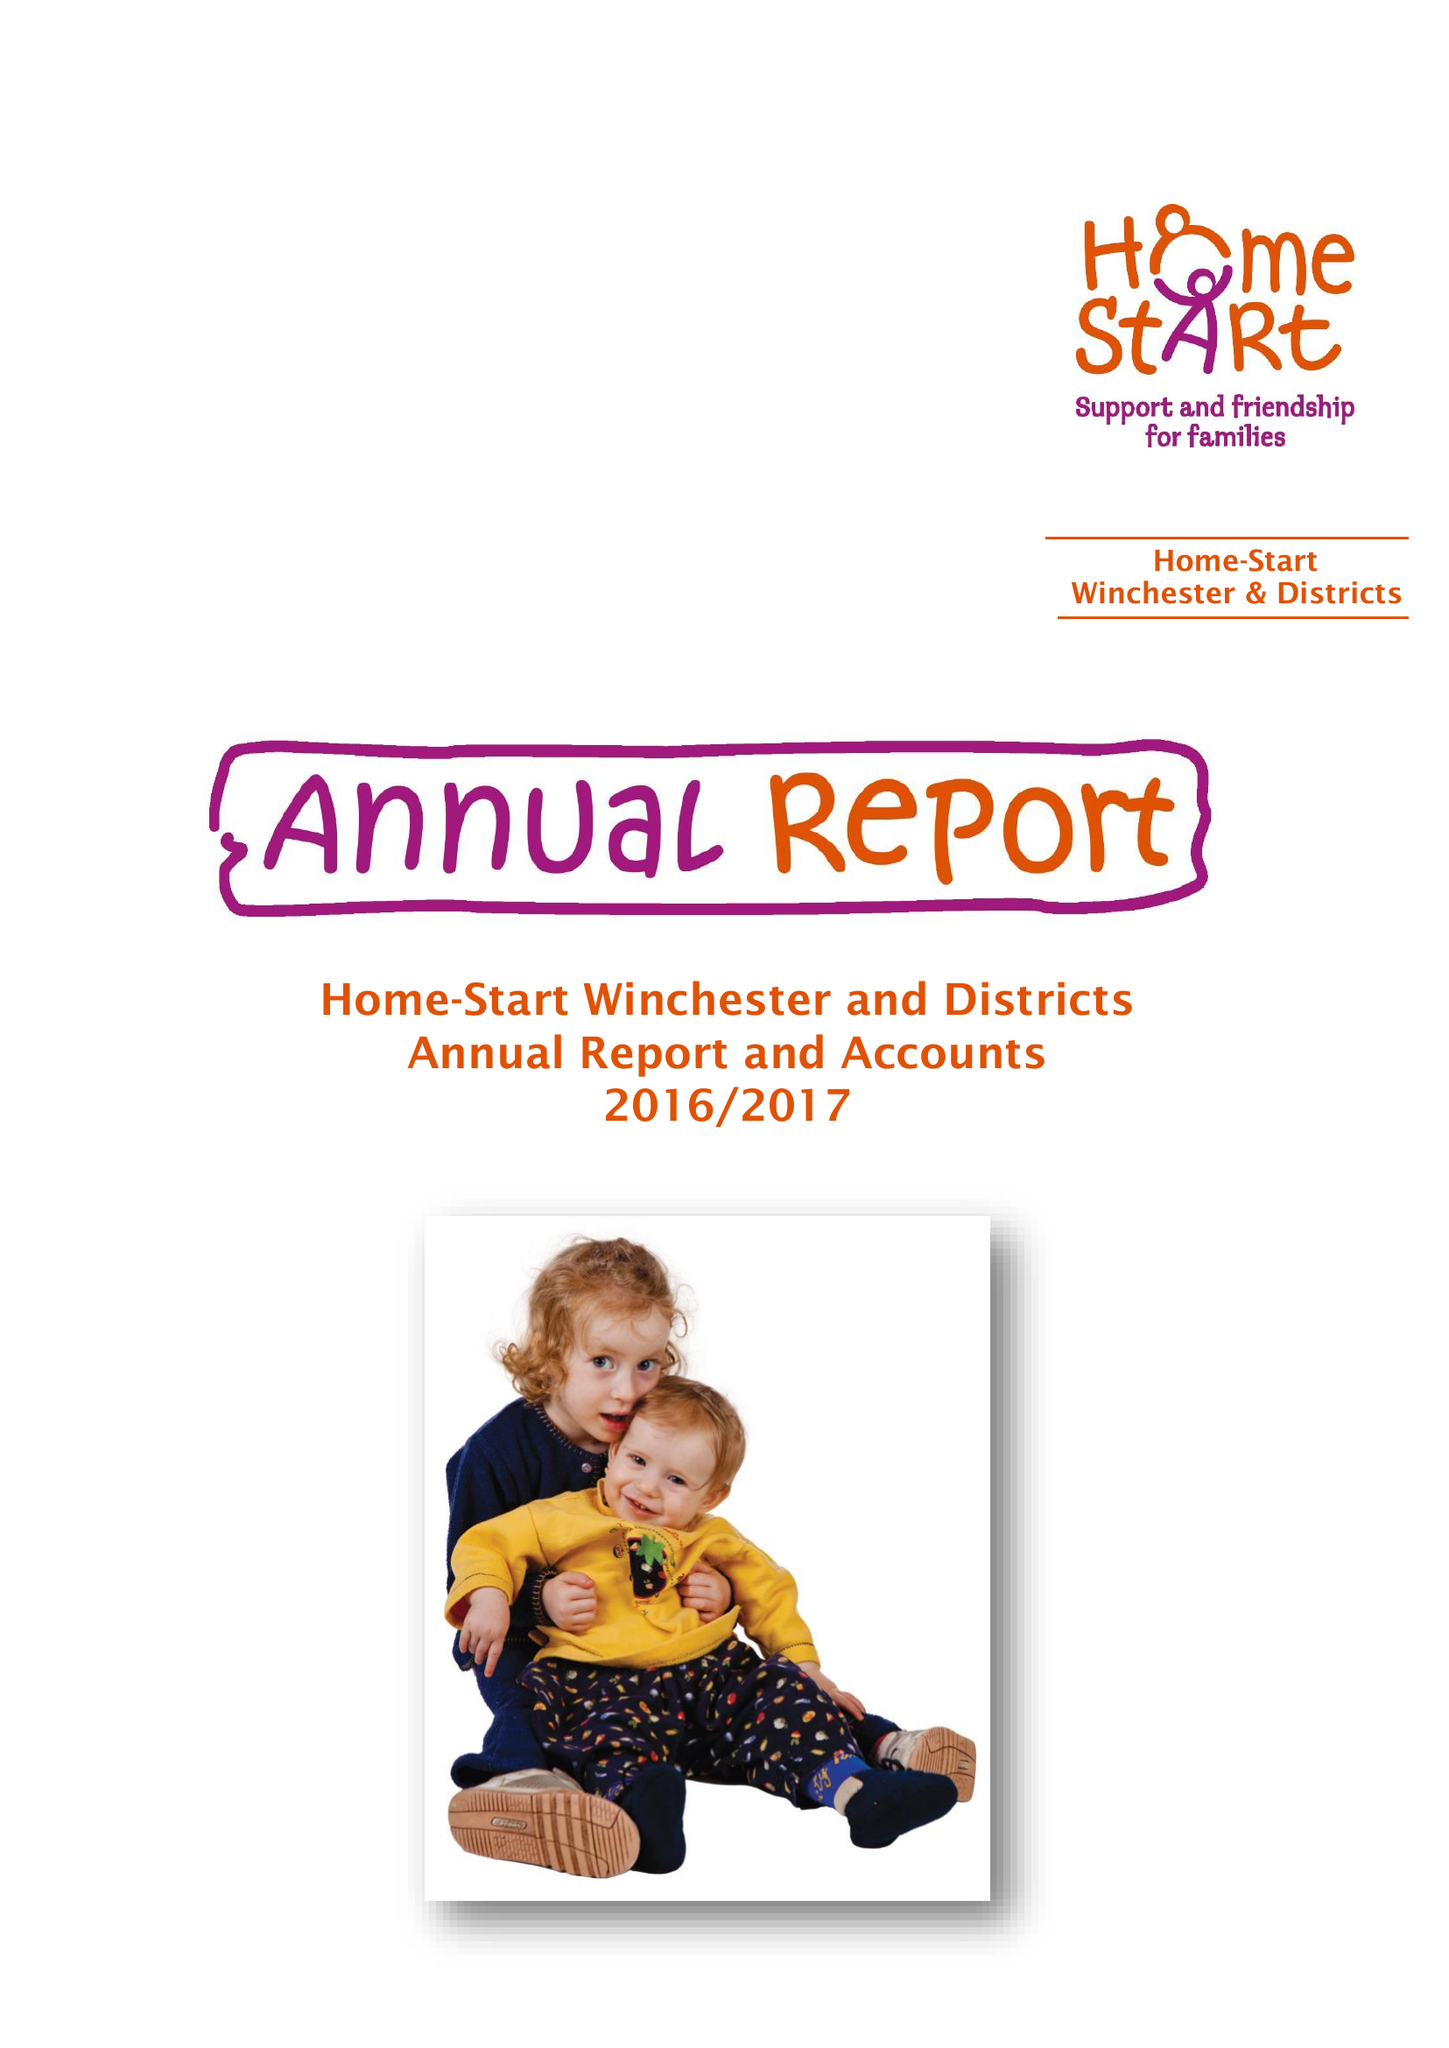What is the value for the address__street_line?
Answer the question using a single word or phrase. BEREWEEKE ROAD 